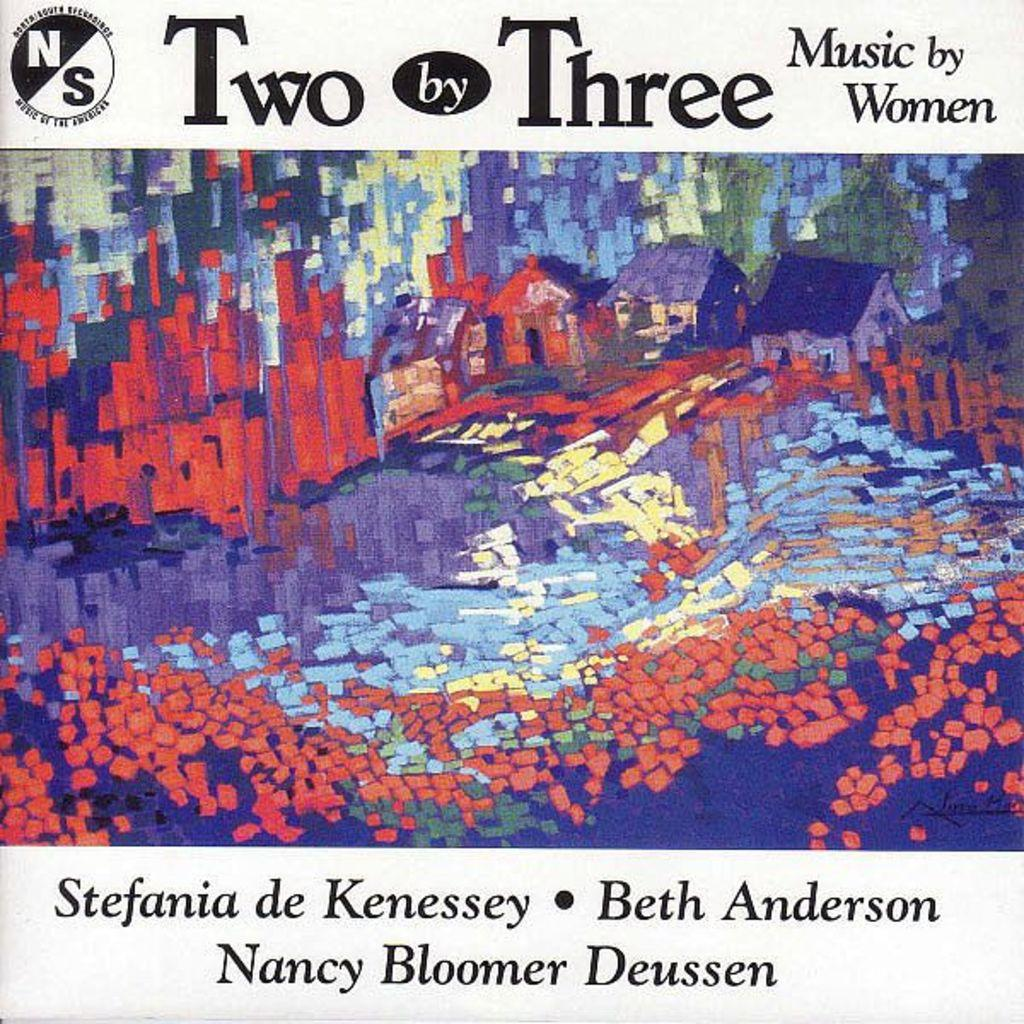<image>
Create a compact narrative representing the image presented. The Album Cover is titled Two by Three: Music by Women. 